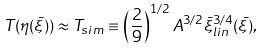Convert formula to latex. <formula><loc_0><loc_0><loc_500><loc_500>T ( \eta ( \bar { \xi } ) ) \approx T _ { s i m } \equiv \left ( \frac { 2 } { 9 } \right ) ^ { 1 / 2 } A ^ { 3 / 2 } \bar { \xi } _ { l i n } ^ { 3 / 4 } ( \bar { \xi } ) ,</formula> 